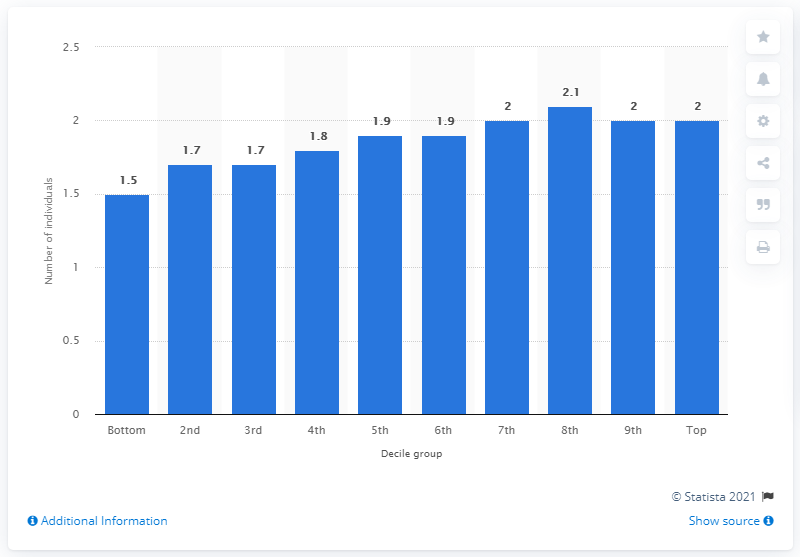Identify some key points in this picture. The average number of adults in the bottom decile group was 1.5. The average number of adults in the eighth and ninth deciles was 2. 